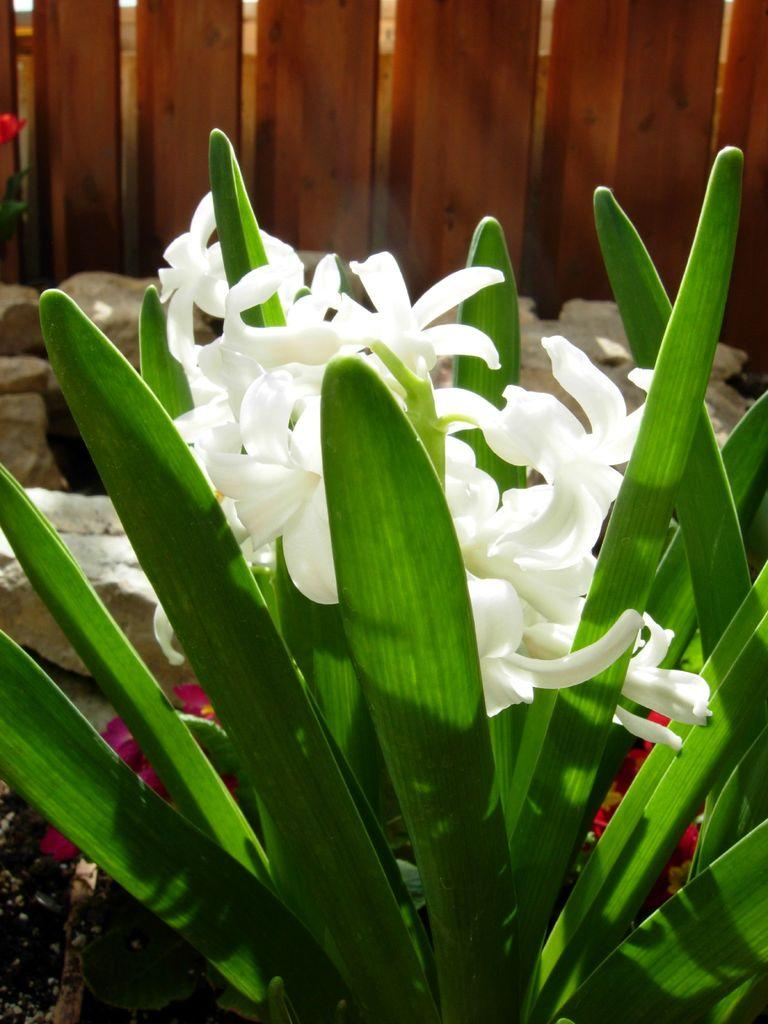What type of plant is visible in the image? There is a plant with white flowers in the image. What is located behind the plant? There are rocks behind the plant. What is the material of the fence behind the plant and rocks? The fence is made of wood. What type of meal is being prepared by the bears in the image? There are no bears or any meal preparation visible in the image. Can you describe the zebra's stripes in the image? There is no zebra present in the image. 